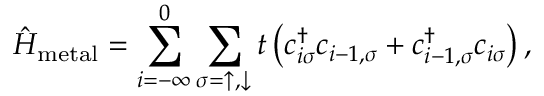<formula> <loc_0><loc_0><loc_500><loc_500>\hat { H } _ { m e t a l } = \sum _ { i = - \infty } ^ { 0 } \sum _ { \sigma = \uparrow , \downarrow } t \left ( c _ { i \sigma } ^ { \dagger } c _ { i - 1 , \sigma } + c _ { i - 1 , \sigma } ^ { \dagger } c _ { i \sigma } \right ) ,</formula> 